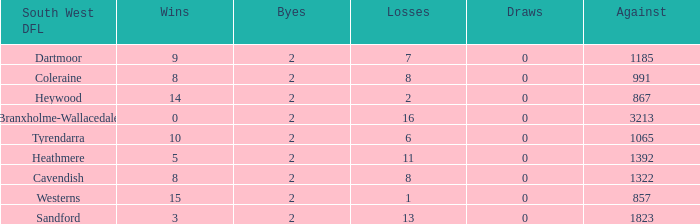How many Draws have a South West DFL of tyrendarra, and less than 10 wins? None. 